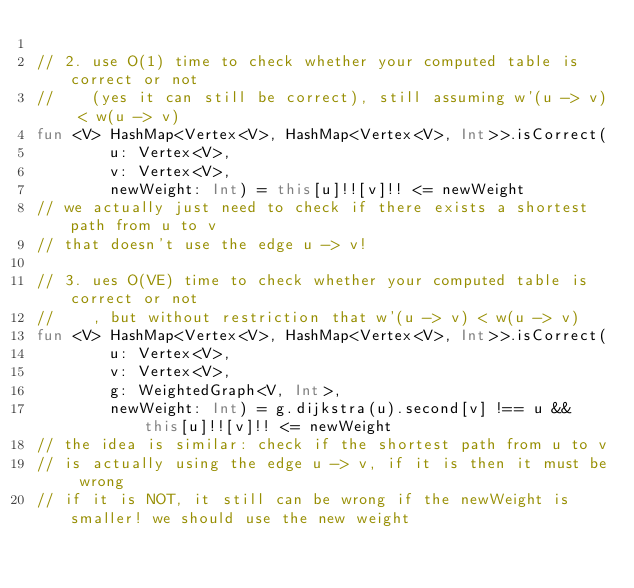Convert code to text. <code><loc_0><loc_0><loc_500><loc_500><_Kotlin_>
// 2. use O(1) time to check whether your computed table is correct or not
//    (yes it can still be correct), still assuming w'(u -> v) < w(u -> v)
fun <V> HashMap<Vertex<V>, HashMap<Vertex<V>, Int>>.isCorrect(
		u: Vertex<V>,
		v: Vertex<V>,
		newWeight: Int) = this[u]!![v]!! <= newWeight
// we actually just need to check if there exists a shortest path from u to v
// that doesn't use the edge u -> v!

// 3. ues O(VE) time to check whether your computed table is correct or not
//    , but without restriction that w'(u -> v) < w(u -> v)
fun <V> HashMap<Vertex<V>, HashMap<Vertex<V>, Int>>.isCorrect(
		u: Vertex<V>,
		v: Vertex<V>,
		g: WeightedGraph<V, Int>,
		newWeight: Int) = g.dijkstra(u).second[v] !== u && this[u]!![v]!! <= newWeight
// the idea is similar: check if the shortest path from u to v
// is actually using the edge u -> v, if it is then it must be wrong
// if it is NOT, it still can be wrong if the newWeight is smaller! we should use the new weight
</code> 